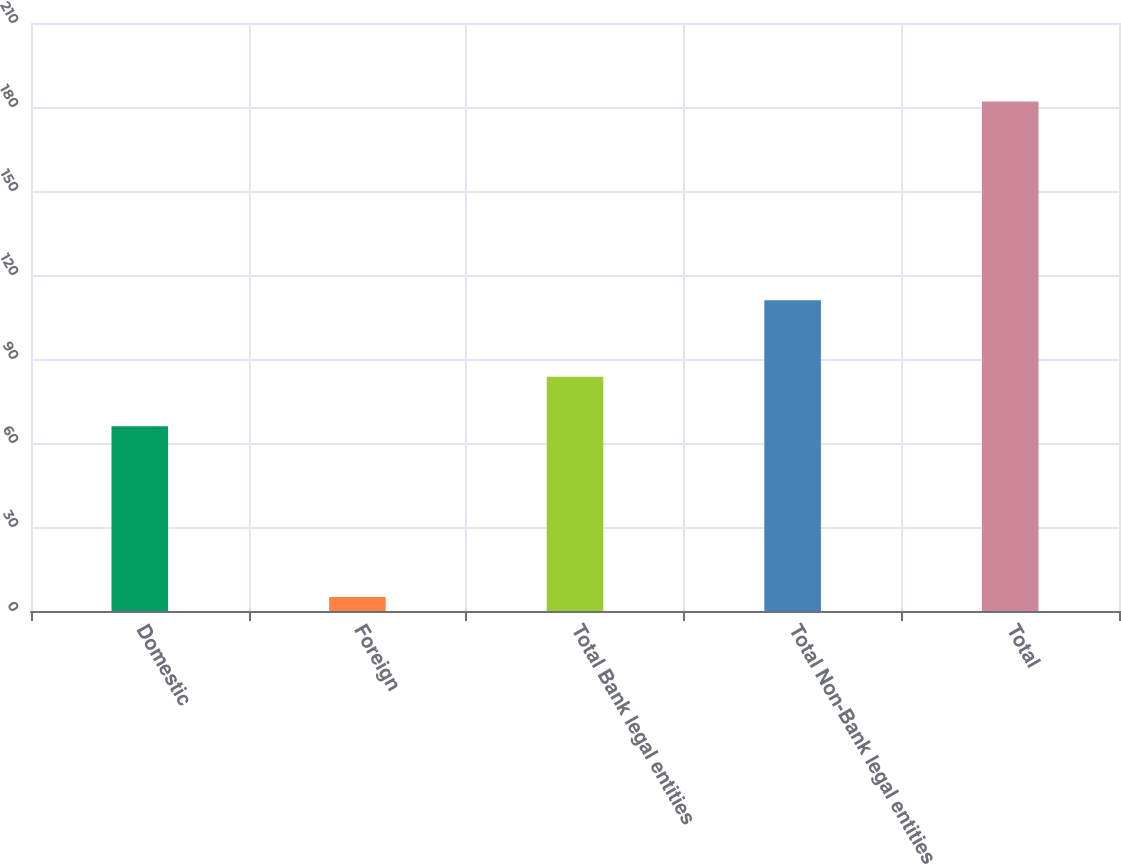Convert chart. <chart><loc_0><loc_0><loc_500><loc_500><bar_chart><fcel>Domestic<fcel>Foreign<fcel>Total Bank legal entities<fcel>Total Non-Bank legal entities<fcel>Total<nl><fcel>66<fcel>5<fcel>83.7<fcel>111<fcel>182<nl></chart> 